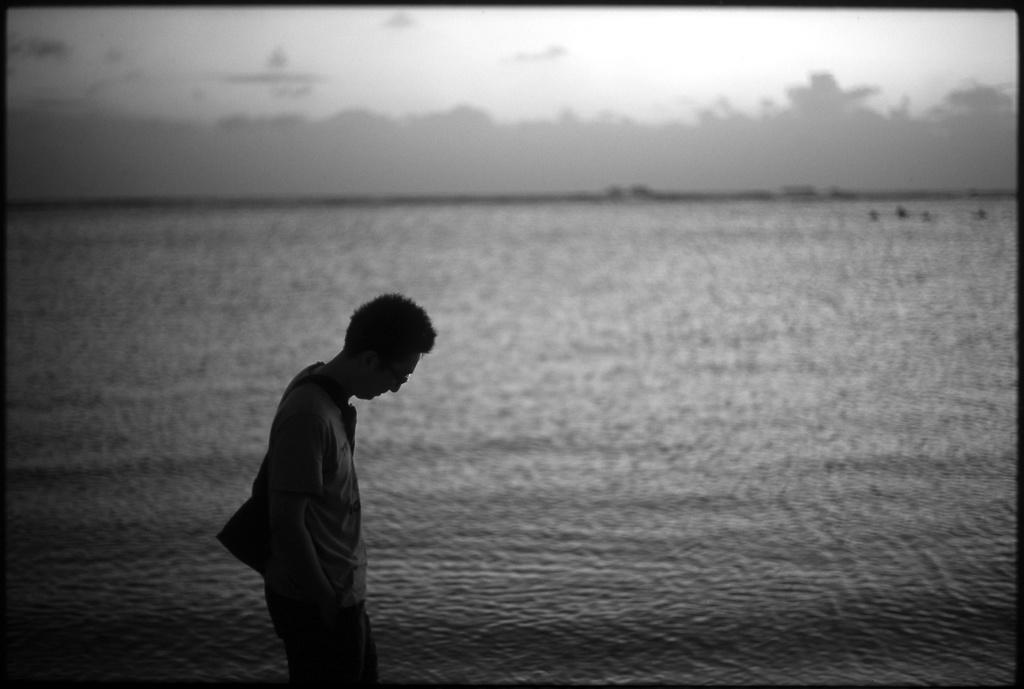What is the color scheme of the image? The image is black and white. Can you describe the person in the image? There is a person standing in the image. What is the person wearing that is visible in the image? The person is wearing a bag. What natural element can be seen in the image? There is water visible in the image. What is visible in the background of the image? The sky is visible in the background of the image. How many geese are swimming in the water in the image? There are no geese present in the image; it only features a person standing and wearing a bag, with water and the sky visible in the background. 